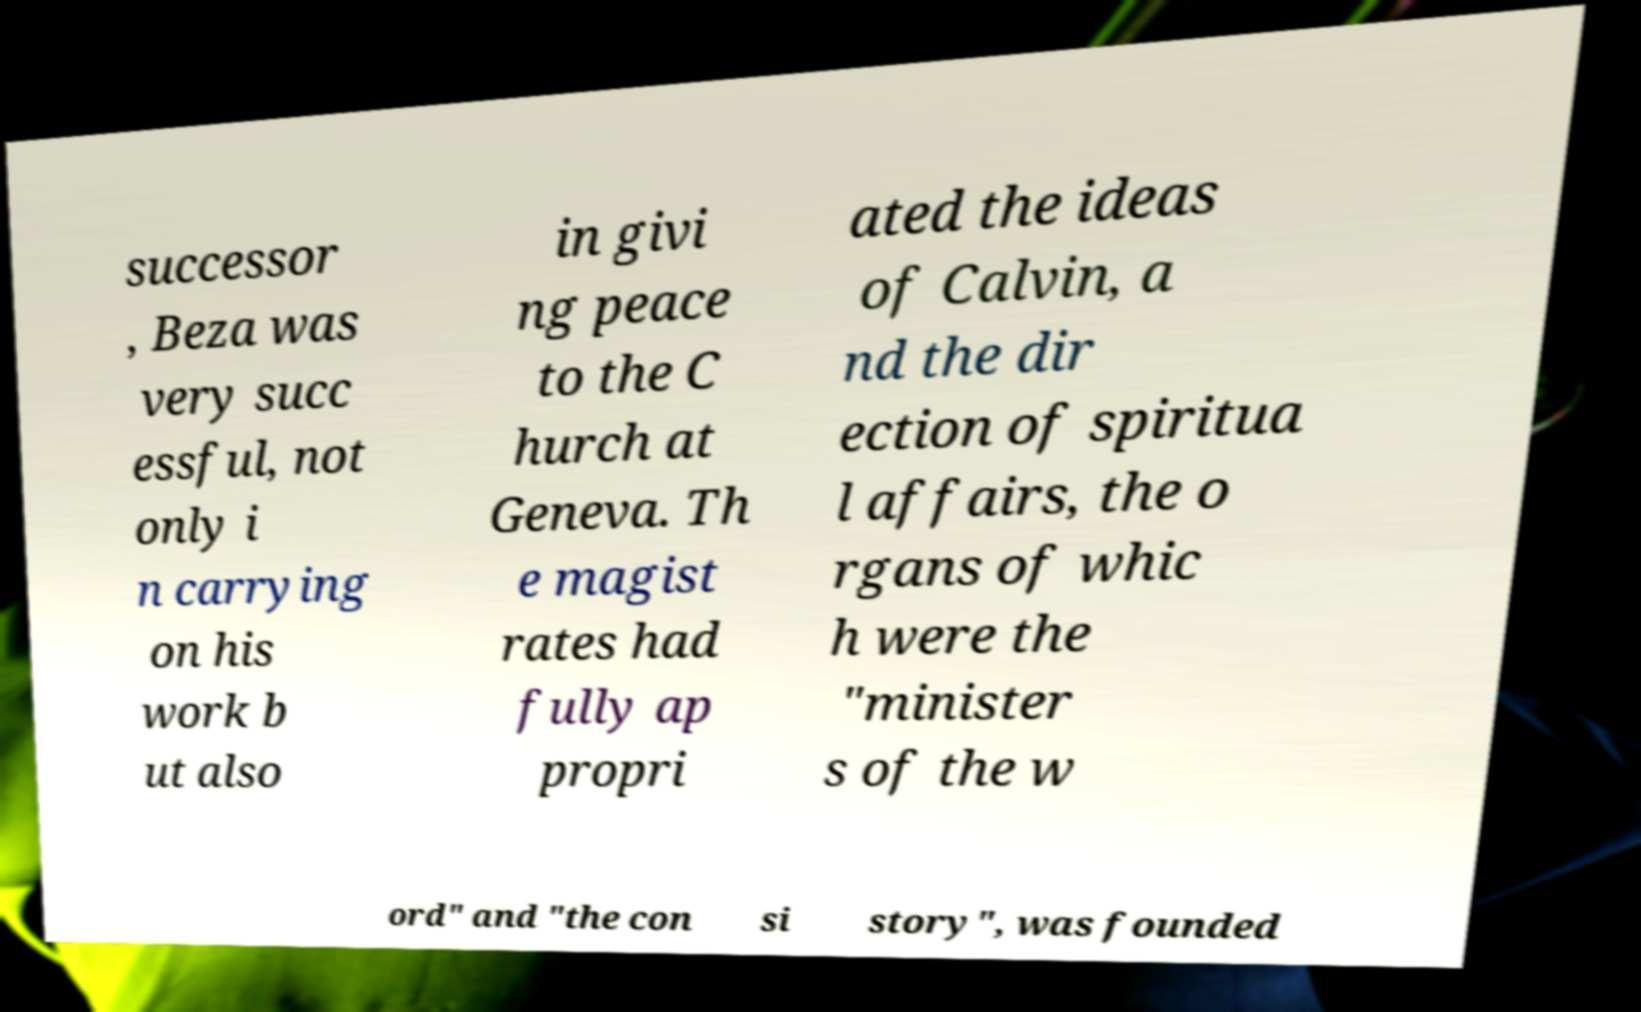There's text embedded in this image that I need extracted. Can you transcribe it verbatim? successor , Beza was very succ essful, not only i n carrying on his work b ut also in givi ng peace to the C hurch at Geneva. Th e magist rates had fully ap propri ated the ideas of Calvin, a nd the dir ection of spiritua l affairs, the o rgans of whic h were the "minister s of the w ord" and "the con si story", was founded 